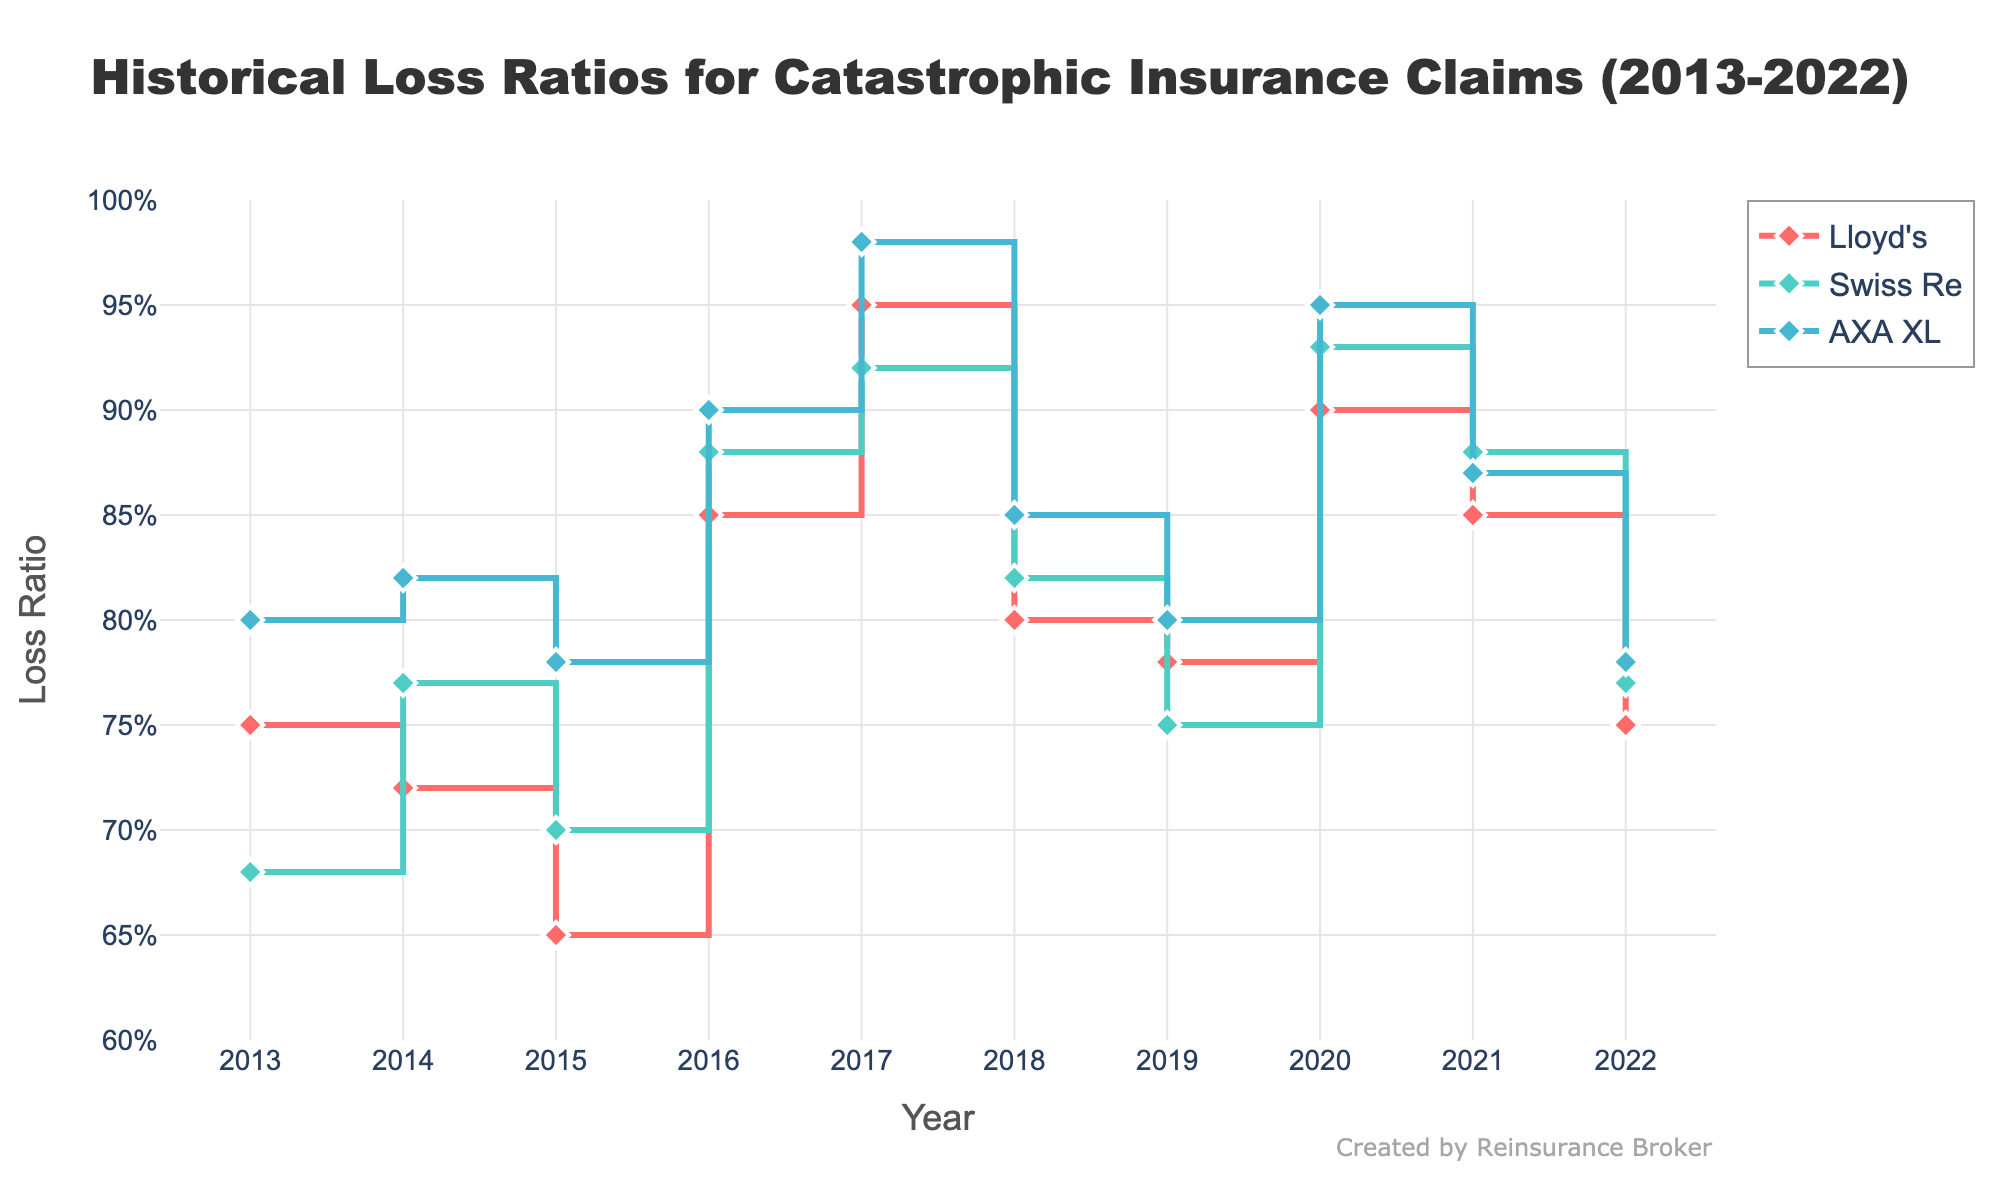What's the title of the plot? The title of the plot is displayed prominently at the top and it reads 'Historical Loss Ratios for Catastrophic Insurance Claims (2013-2022)'.
Answer: Historical Loss Ratios for Catastrophic Insurance Claims (2013-2022) What is the general trend of the loss ratio for Lloyd's from 2013 to 2022? To identify the trend, observe the line for Lloyd's which is represented with a unique color. The loss ratio starts at 0.75 in 2013, fluctuates over the years, reaching a peak in 2017 at 0.95, and then generally decreases to 0.75 by 2022.
Answer: Increasing till 2017 then generally decreasing In which year did AXA XL have the highest loss ratio? The plot shows each year's data point for AXA XL, represented by a specific color and diamond markers. The highest point is at 0.98 in the year 2017.
Answer: 2017 Between 2017 and 2018, which insurance company experienced the largest decrease in loss ratio? Compare the change in loss ratios from 2017 to 2018 for all companies. Lloyd's went from 0.95 to 0.80, Swiss Re from 0.92 to 0.82, and AXA XL from 0.98 to 0.85. The largest decrease is seen in AXA XL, with a drop of 0.13.
Answer: AXA XL What was the average loss ratio for Swiss Re from 2013 to 2022? To calculate the average, sum up all the loss ratios for Swiss Re from 2013 to 2022 and divide by the number of years. The sum is (0.68 + 0.77 + 0.70 + 0.88 + 0.92 + 0.82 + 0.75 + 0.93 + 0.88 + 0.77) = 8.10. Dividing by 10 years gives an average of 0.81.
Answer: 0.81 Which company had the most stable trend in loss ratios? To determine stability, observe the smoothness and range of the lines for each company. Swiss Re's line appears to have the least variation and fluctuation in loss ratios over the years compared to Lloyd's and AXA XL.
Answer: Swiss Re What is the loss ratio range for Lloyd's between 2013 and 2022? To find the range, identify the minimum and maximum data points for Lloyd's. The lowest point is 0.65 in 2015, and the highest is 0.95 in 2017. The range is 0.95 - 0.65 = 0.30.
Answer: 0.30 Comparing the years 2015 and 2020, which insurance companies show an increase in loss ratio? Compare the loss ratios in 2015 and 2020 for each company. Lloyd's increases from 0.65 to 0.90, Swiss Re increases from 0.70 to 0.93, and AXA XL increases from 0.78 to 0.95. All companies show an increase.
Answer: Lloyd's, Swiss Re, AXA XL How did the loss ratio for Lloyd's compare to Swiss Re in 2022? Look at the data markers for 2022 for both Lloyd's and Swiss Re. Lloyd's has a loss ratio of 0.75 and Swiss Re has 0.77. Thus, Lloyd's loss ratio is slightly lower than Swiss Re's in 2022.
Answer: Lloyd's is lower Which company shows the first instance of a loss ratio above 0.90? Identify the year and company on the plot where the loss ratio first exceeds 0.90. In 2016, AXA XL reached 0.90, marking the first instance for any company.
Answer: AXA XL in 2016 